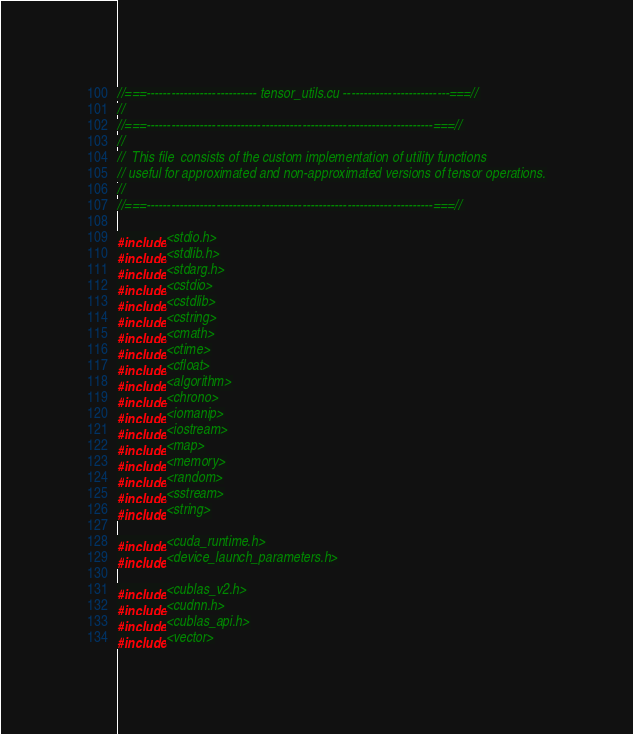Convert code to text. <code><loc_0><loc_0><loc_500><loc_500><_Cuda_>//===--------------------------- tensor_utils.cu --------------------------===//
//
//===----------------------------------------------------------------------===//
//
//  This file  consists of the custom implementation of utility functions
// useful for approximated and non-approximated versions of tensor operations.
//
//===----------------------------------------------------------------------===//

#include <stdio.h>
#include <stdlib.h>
#include <stdarg.h>
#include <cstdio>
#include <cstdlib>
#include <cstring>
#include <cmath>
#include <ctime>
#include <cfloat>
#include <algorithm>
#include <chrono>
#include <iomanip>
#include <iostream>
#include <map>
#include <memory>
#include <random>
#include <sstream>
#include <string>

#include <cuda_runtime.h>
#include <device_launch_parameters.h>

#include <cublas_v2.h>
#include <cudnn.h>
#include <cublas_api.h>
#include <vector>
</code> 